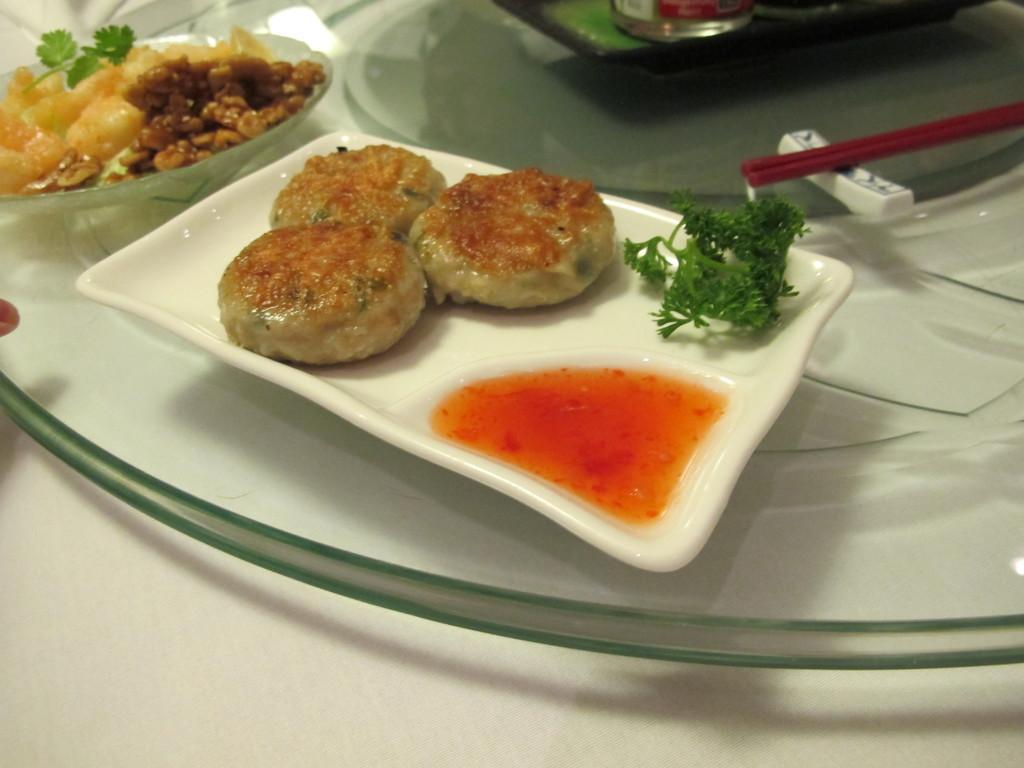Describe this image in one or two sentences. In the center of the image we can see food in plate placed on the table. 